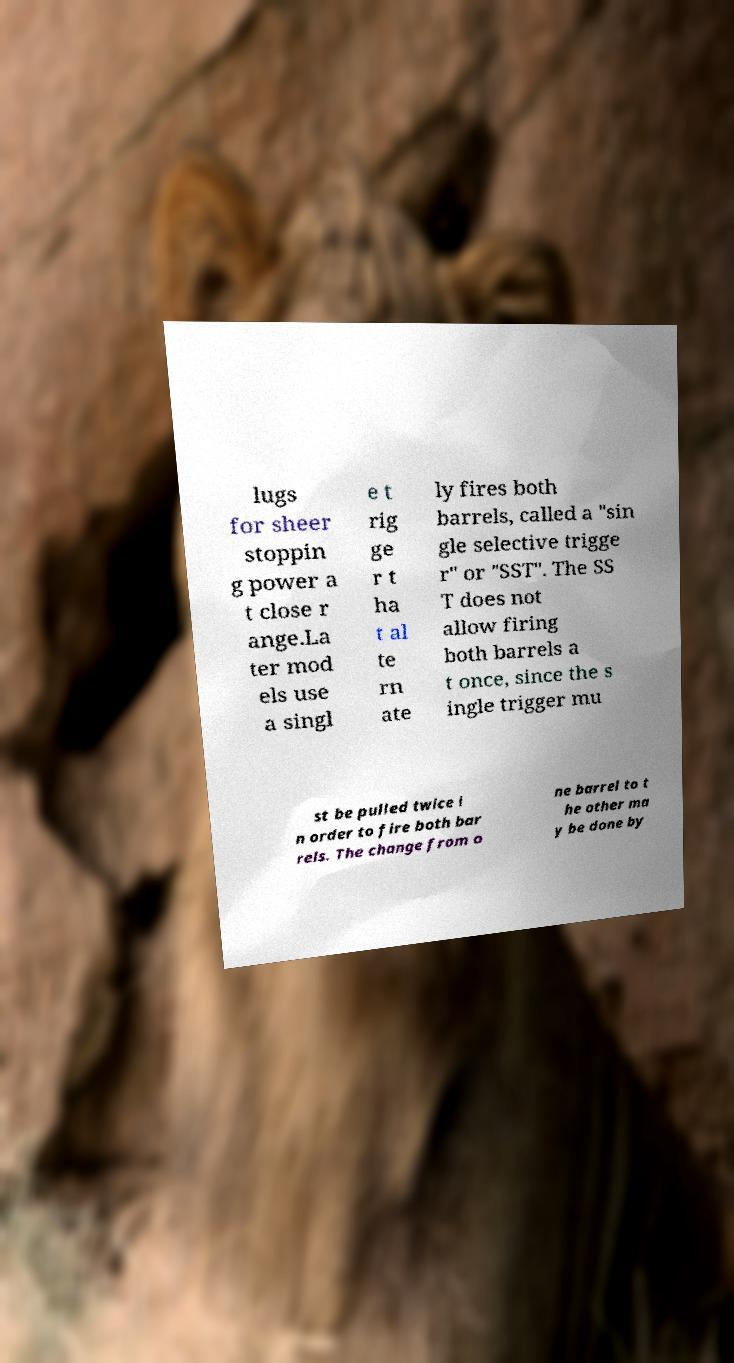Could you assist in decoding the text presented in this image and type it out clearly? lugs for sheer stoppin g power a t close r ange.La ter mod els use a singl e t rig ge r t ha t al te rn ate ly fires both barrels, called a "sin gle selective trigge r" or "SST". The SS T does not allow firing both barrels a t once, since the s ingle trigger mu st be pulled twice i n order to fire both bar rels. The change from o ne barrel to t he other ma y be done by 